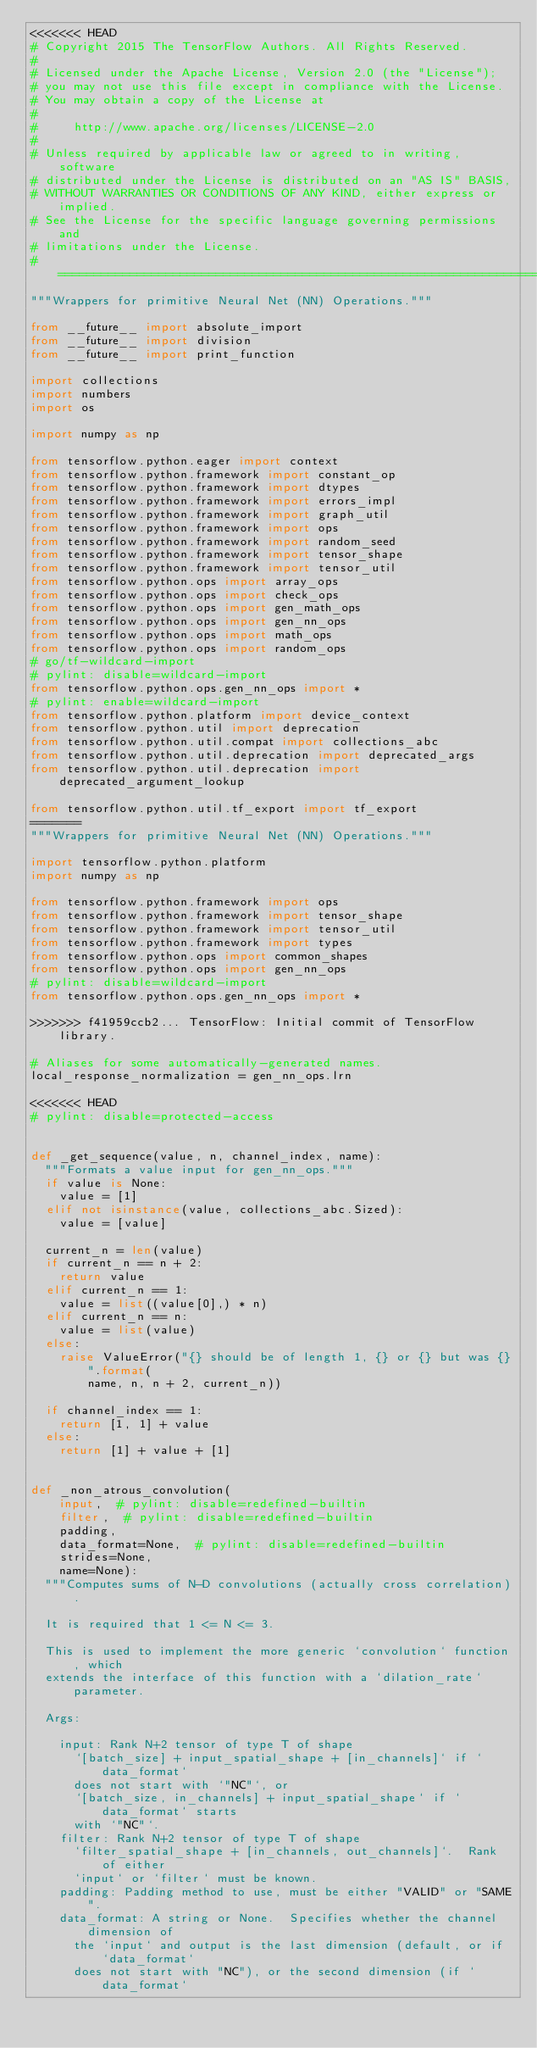Convert code to text. <code><loc_0><loc_0><loc_500><loc_500><_Python_><<<<<<< HEAD
# Copyright 2015 The TensorFlow Authors. All Rights Reserved.
#
# Licensed under the Apache License, Version 2.0 (the "License");
# you may not use this file except in compliance with the License.
# You may obtain a copy of the License at
#
#     http://www.apache.org/licenses/LICENSE-2.0
#
# Unless required by applicable law or agreed to in writing, software
# distributed under the License is distributed on an "AS IS" BASIS,
# WITHOUT WARRANTIES OR CONDITIONS OF ANY KIND, either express or implied.
# See the License for the specific language governing permissions and
# limitations under the License.
# ==============================================================================
"""Wrappers for primitive Neural Net (NN) Operations."""

from __future__ import absolute_import
from __future__ import division
from __future__ import print_function

import collections
import numbers
import os

import numpy as np

from tensorflow.python.eager import context
from tensorflow.python.framework import constant_op
from tensorflow.python.framework import dtypes
from tensorflow.python.framework import errors_impl
from tensorflow.python.framework import graph_util
from tensorflow.python.framework import ops
from tensorflow.python.framework import random_seed
from tensorflow.python.framework import tensor_shape
from tensorflow.python.framework import tensor_util
from tensorflow.python.ops import array_ops
from tensorflow.python.ops import check_ops
from tensorflow.python.ops import gen_math_ops
from tensorflow.python.ops import gen_nn_ops
from tensorflow.python.ops import math_ops
from tensorflow.python.ops import random_ops
# go/tf-wildcard-import
# pylint: disable=wildcard-import
from tensorflow.python.ops.gen_nn_ops import *
# pylint: enable=wildcard-import
from tensorflow.python.platform import device_context
from tensorflow.python.util import deprecation
from tensorflow.python.util.compat import collections_abc
from tensorflow.python.util.deprecation import deprecated_args
from tensorflow.python.util.deprecation import deprecated_argument_lookup

from tensorflow.python.util.tf_export import tf_export
=======
"""Wrappers for primitive Neural Net (NN) Operations."""

import tensorflow.python.platform
import numpy as np

from tensorflow.python.framework import ops
from tensorflow.python.framework import tensor_shape
from tensorflow.python.framework import tensor_util
from tensorflow.python.framework import types
from tensorflow.python.ops import common_shapes
from tensorflow.python.ops import gen_nn_ops
# pylint: disable=wildcard-import
from tensorflow.python.ops.gen_nn_ops import *

>>>>>>> f41959ccb2... TensorFlow: Initial commit of TensorFlow library.

# Aliases for some automatically-generated names.
local_response_normalization = gen_nn_ops.lrn

<<<<<<< HEAD
# pylint: disable=protected-access


def _get_sequence(value, n, channel_index, name):
  """Formats a value input for gen_nn_ops."""
  if value is None:
    value = [1]
  elif not isinstance(value, collections_abc.Sized):
    value = [value]

  current_n = len(value)
  if current_n == n + 2:
    return value
  elif current_n == 1:
    value = list((value[0],) * n)
  elif current_n == n:
    value = list(value)
  else:
    raise ValueError("{} should be of length 1, {} or {} but was {}".format(
        name, n, n + 2, current_n))

  if channel_index == 1:
    return [1, 1] + value
  else:
    return [1] + value + [1]


def _non_atrous_convolution(
    input,  # pylint: disable=redefined-builtin
    filter,  # pylint: disable=redefined-builtin
    padding,
    data_format=None,  # pylint: disable=redefined-builtin
    strides=None,
    name=None):
  """Computes sums of N-D convolutions (actually cross correlation).

  It is required that 1 <= N <= 3.

  This is used to implement the more generic `convolution` function, which
  extends the interface of this function with a `dilation_rate` parameter.

  Args:

    input: Rank N+2 tensor of type T of shape
      `[batch_size] + input_spatial_shape + [in_channels]` if `data_format`
      does not start with `"NC"`, or
      `[batch_size, in_channels] + input_spatial_shape` if `data_format` starts
      with `"NC"`.
    filter: Rank N+2 tensor of type T of shape
      `filter_spatial_shape + [in_channels, out_channels]`.  Rank of either
      `input` or `filter` must be known.
    padding: Padding method to use, must be either "VALID" or "SAME".
    data_format: A string or None.  Specifies whether the channel dimension of
      the `input` and output is the last dimension (default, or if `data_format`
      does not start with "NC"), or the second dimension (if `data_format`</code> 